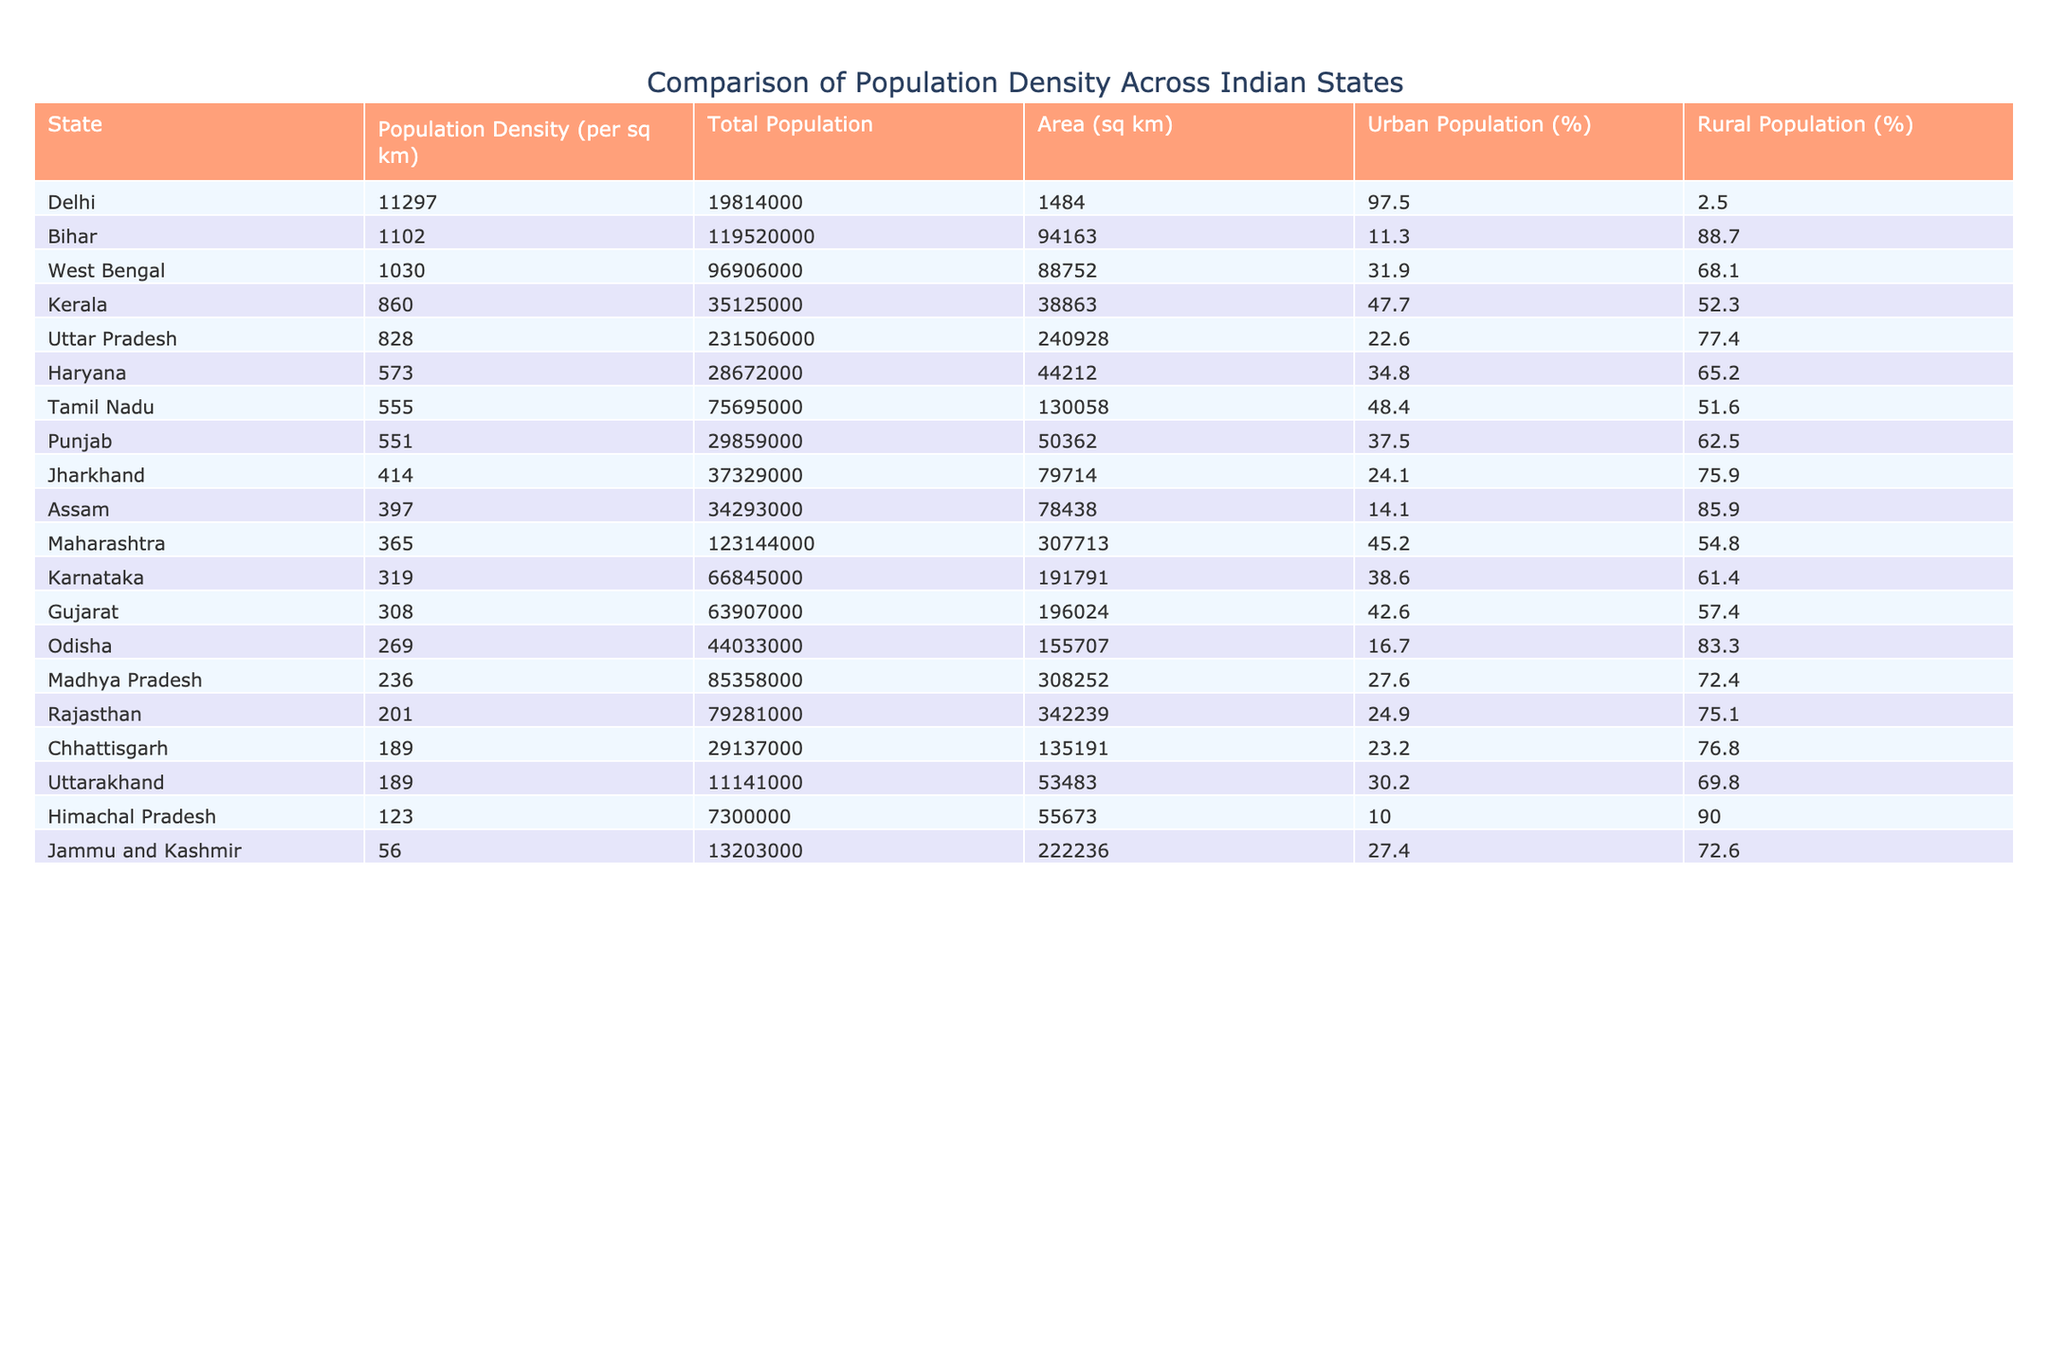What is the population density of Bihar? The table shows that the population density of Bihar is listed as 1102 per square kilometer.
Answer: 1102 Which state has the highest population density? From the table, Delhi has the highest population density at 11297 per square kilometer.
Answer: 11297 What is the total population of Maharashtra? The table indicates that the total population of Maharashtra is 123,144,000.
Answer: 123144000 Is the urban population percentage in Kerala greater than 50%? According to the table, the urban population percentage in Kerala is 47.7%, which is less than 50%.
Answer: No How does the population density of Uttar Pradesh compare to that of Tamil Nadu? Uttar Pradesh has a population density of 828 per square kilometer, while Tamil Nadu has a density of 555. Therefore, Uttar Pradesh has a higher density.
Answer: Uttar Pradesh is higher What is the average population density of the states listed in the table? To find the average, we sum the population densities: (828 + 1102 + 1030 + 365 + 236 + 555 + 201 + 319 + 308 + 269 + 860 + 414 + 397 + 551 + 189 + 573 + 11297 + 56 + 189 + 123) = 12224. The count of states is 18, and the average density is 12224 / 18 = 678. However, the presence of Delhi significantly skews this average. It's better to find the average excluding it, resulting in (12224 - 11297) / 17 = 54. The average density without Delhi is approximately 666.
Answer: Approximately 666 Which state has the lowest population density? The table shows that Jammu and Kashmir has the lowest population density of 56 per square kilometer.
Answer: 56 If you combine the urban population percentages of Uttar Pradesh and Odisha, does it exceed 40%? Uttar Pradesh has an urban population percentage of 22.6% and Odisha has 16.7%. Their combined percentage is 22.6 + 16.7 = 39.3%, which does not exceed 40%.
Answer: No What is the difference in area (sq km) between Rajasthan and Tamil Nadu? The area of Rajasthan is 342,239 sq km and the area of Tamil Nadu is 130,058 sq km. The difference is 342,239 - 130,058 = 212,181 sq km.
Answer: 212181 